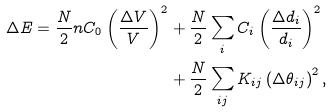Convert formula to latex. <formula><loc_0><loc_0><loc_500><loc_500>\Delta E = { \frac { N } { 2 } } n C _ { 0 } \left ( \frac { \Delta V } { V } \right ) ^ { 2 } & + \frac { N } { 2 } \sum _ { i } C _ { i } \left ( \frac { \Delta d _ { i } } { d _ { i } } \right ) ^ { 2 } \\ & + \frac { N } { 2 } \sum _ { i j } K _ { i j } \left ( \Delta \theta _ { i j } \right ) ^ { 2 } ,</formula> 